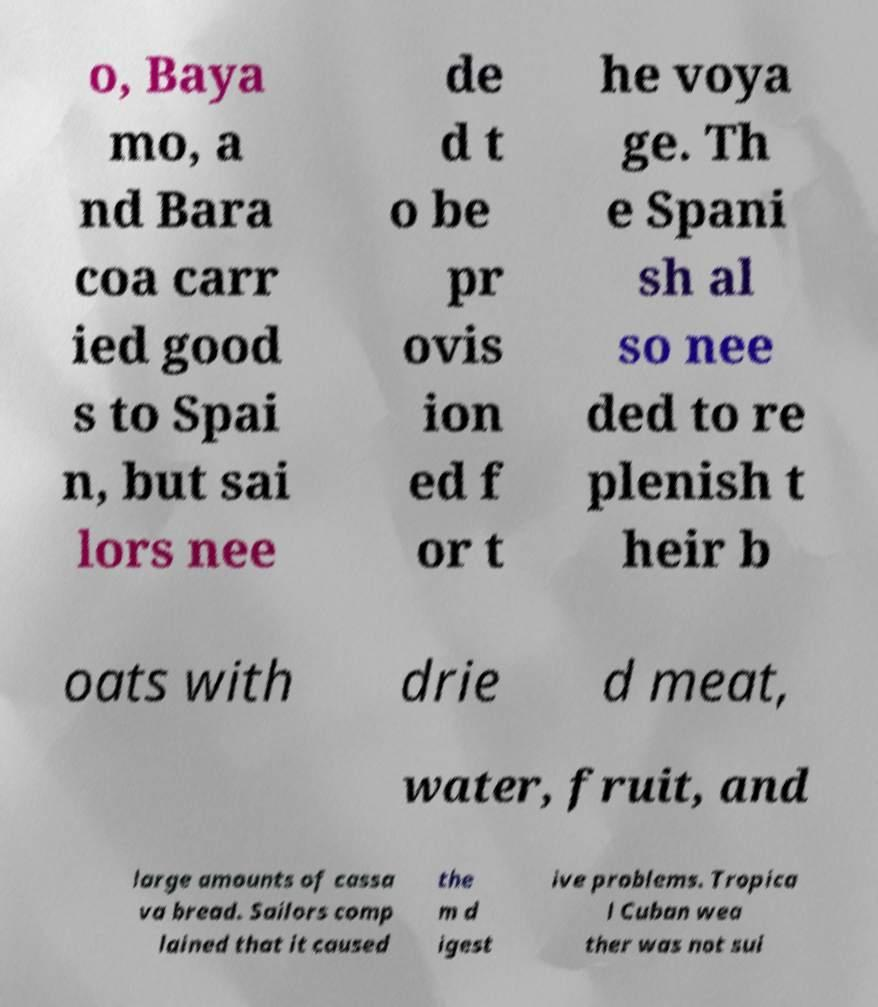There's text embedded in this image that I need extracted. Can you transcribe it verbatim? o, Baya mo, a nd Bara coa carr ied good s to Spai n, but sai lors nee de d t o be pr ovis ion ed f or t he voya ge. Th e Spani sh al so nee ded to re plenish t heir b oats with drie d meat, water, fruit, and large amounts of cassa va bread. Sailors comp lained that it caused the m d igest ive problems. Tropica l Cuban wea ther was not sui 